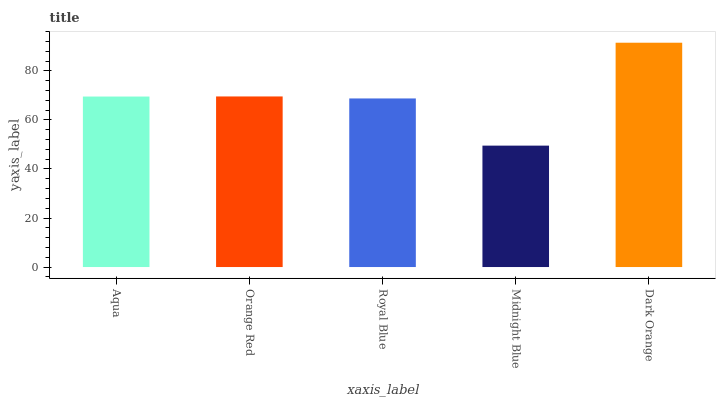Is Midnight Blue the minimum?
Answer yes or no. Yes. Is Dark Orange the maximum?
Answer yes or no. Yes. Is Orange Red the minimum?
Answer yes or no. No. Is Orange Red the maximum?
Answer yes or no. No. Is Orange Red greater than Aqua?
Answer yes or no. Yes. Is Aqua less than Orange Red?
Answer yes or no. Yes. Is Aqua greater than Orange Red?
Answer yes or no. No. Is Orange Red less than Aqua?
Answer yes or no. No. Is Aqua the high median?
Answer yes or no. Yes. Is Aqua the low median?
Answer yes or no. Yes. Is Dark Orange the high median?
Answer yes or no. No. Is Midnight Blue the low median?
Answer yes or no. No. 